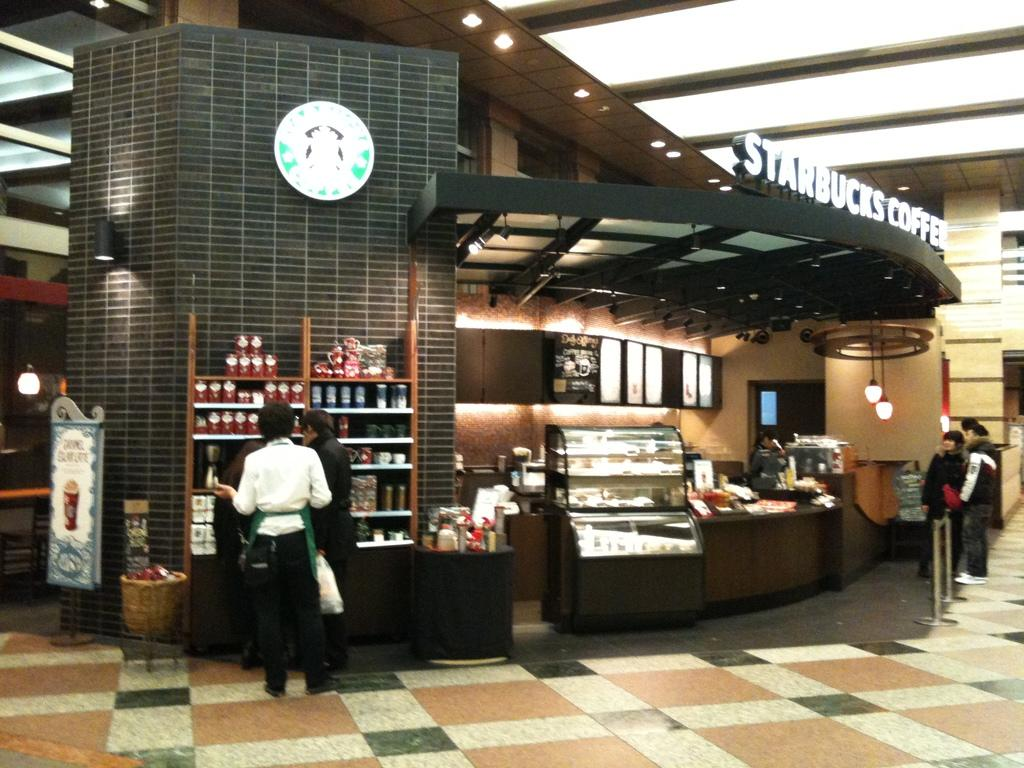What can be seen in the image? There are people standing in the image. Where are the people standing? The people are standing on a floor. What is visible in the background of the image? There is a shop in the background of the image. What can be seen inside the shop? There are items visible in the shop. What is above the people in the image? There is a roof visible in the image. What can be seen providing illumination in the image? There are lights visible in the image. What song is being sung by the people in the image? There is no indication in the image that the people are singing a song. 